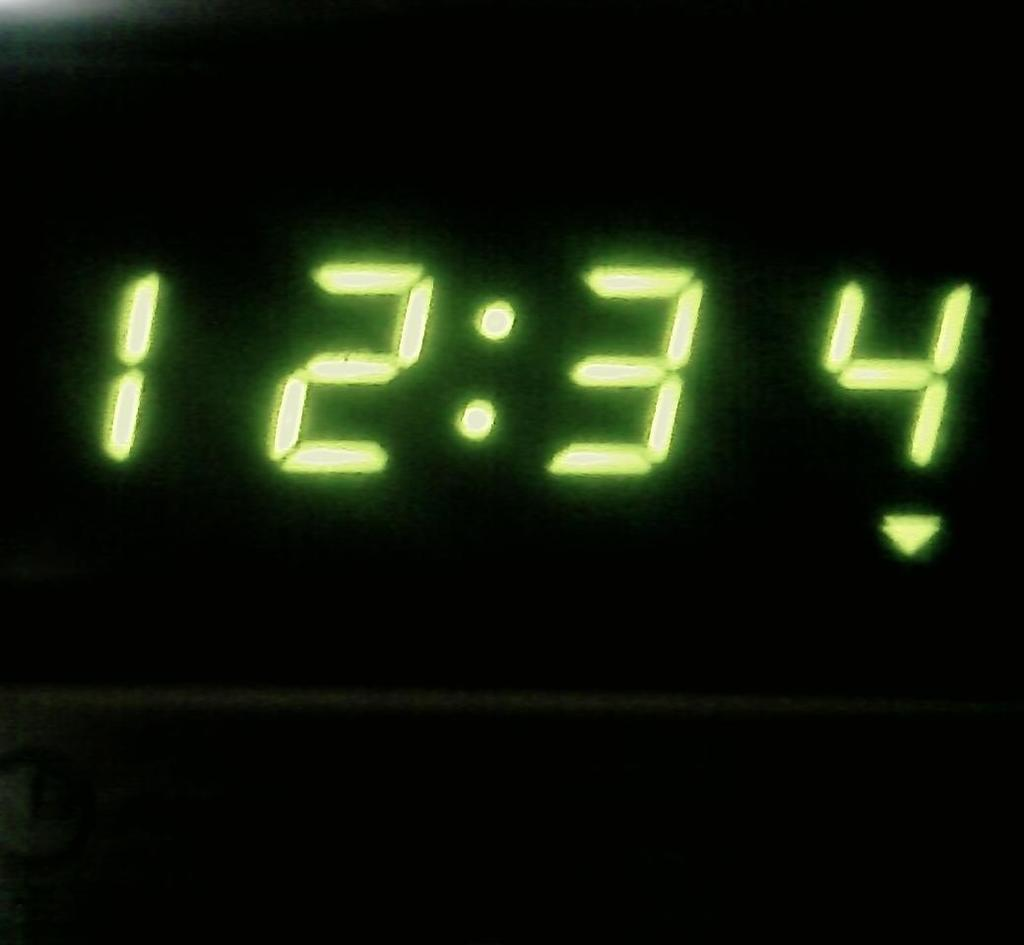Provide a one-sentence caption for the provided image. A clock that has 12:34 on its screen in glowing numbers. 